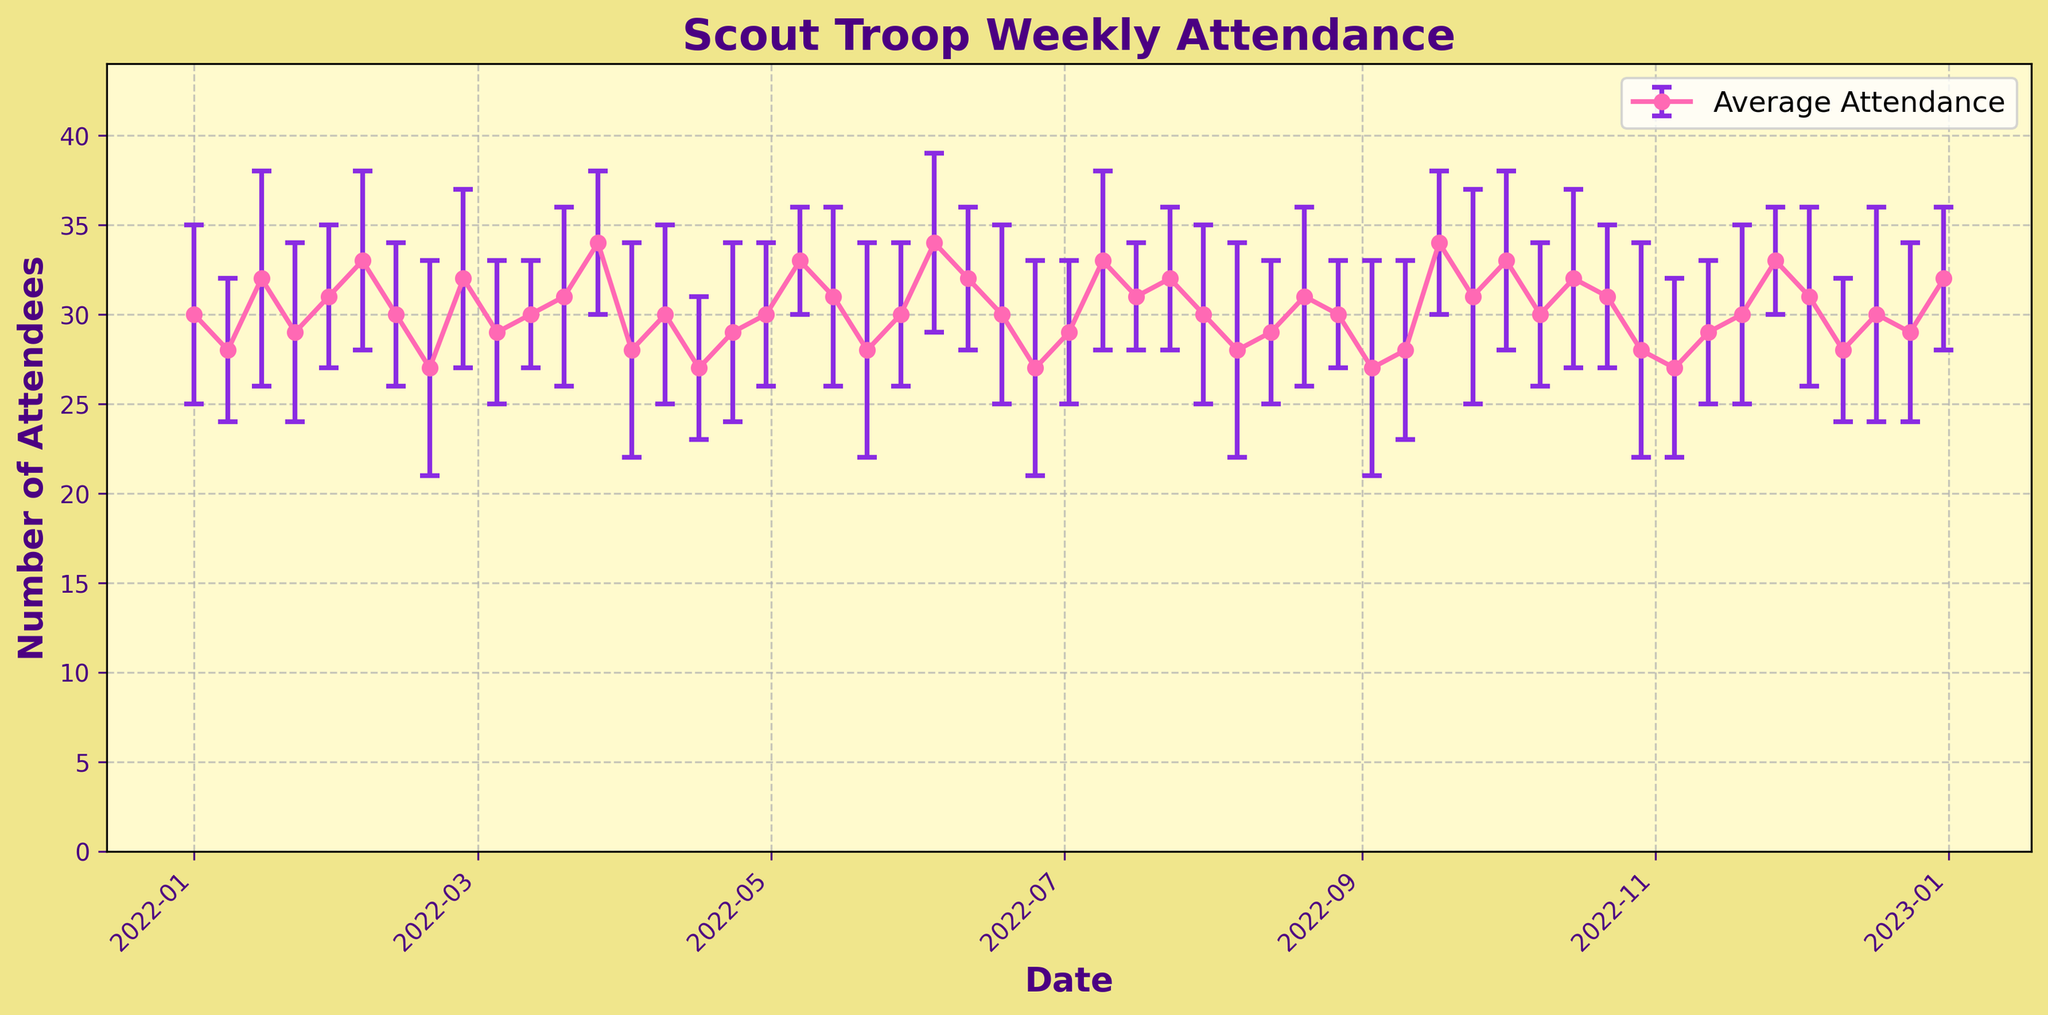What is the title of the figure? The title of the figure is displayed at the top, providing a summary of what the plot represents. Looking at the plot, the title reads "Scout Troop Weekly Attendance".
Answer: Scout Troop Weekly Attendance What does the y-axis represent in the plot? The y-axis usually describes what is being measured. In this figure, the y-axis is labeled "Number of Attendees", meaning it represents the number of people attending the scout meetings each week.
Answer: Number of Attendees What is the average attendance on February 5, 2022? Locate the data point corresponding to the week of February 5, 2022. The plot marker at this date shows the average attendance value. The average attendance on this date is 33 attendees.
Answer: 33 How many times does the attendance exceed 32 attendees? Identify occurrences in the plot where the y-value is greater than 32. This happens on January 15, March 26, May 7, June 4, July 9, September 17, October 1, and November 26, summing up to 8 times.
Answer: 8 What is the difference between the highest and lowest average attendance? Find the highest and lowest average attendance values by examining the peaks and troughs in the plot. The highest is 34 (multiple dates) and the lowest is 27 (multiple dates). The difference is 34 - 27 = 7 attendees.
Answer: 7 Which month has the highest average attendance? By examining the plot and focusing on months with peaks, September has a peak of 34 on the 17th, indicating it has one of the highest average attendances.
Answer: September How does the attendance fluctuation on March 5, 2022, compare to that on April 9, 2022? Compare the error bars on these two dates. March 5 has an attendance fluctuation of 4, and April 9 has an attendance fluctuation of 5. April 9 has a higher fluctuation.
Answer: April 9 has a higher fluctuation On which date does the figure have the lowest average attendance with the largest error bar? Identify the data points with the lowest average attendance and check their error bars. The lowest attendance is 27 (multiple dates), and the one with the largest error bar (6) is April 16.
Answer: April 16 